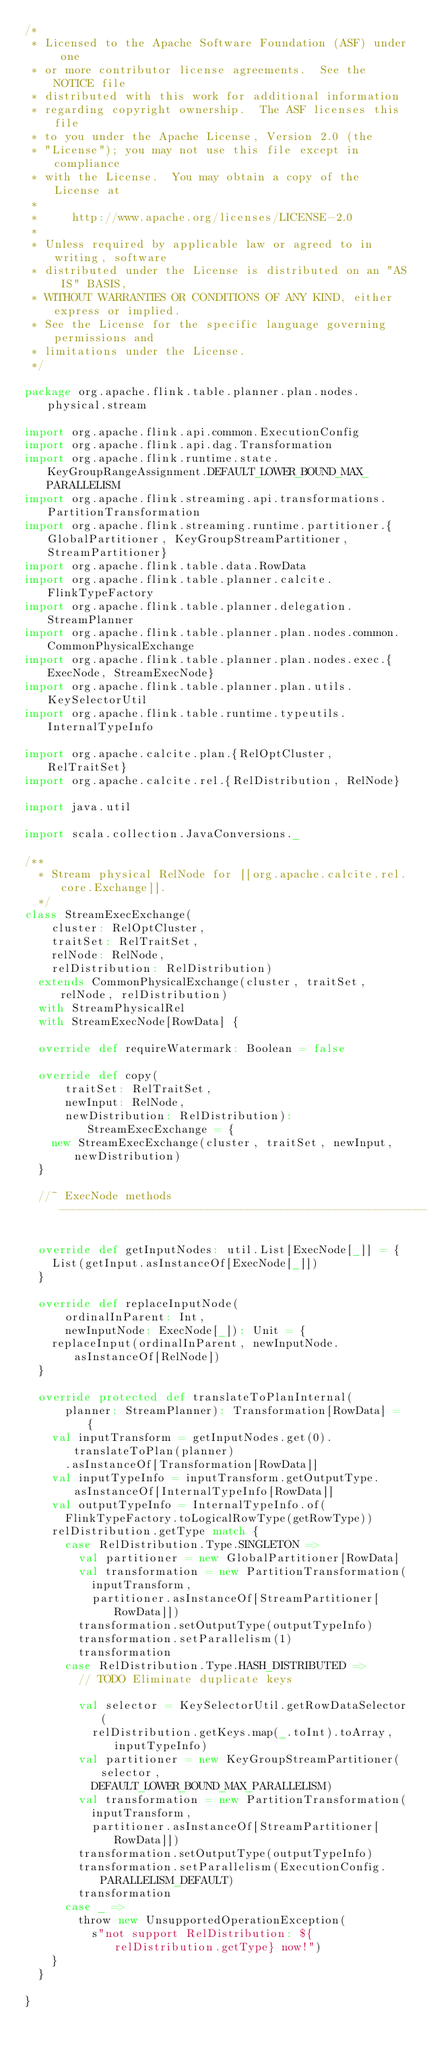<code> <loc_0><loc_0><loc_500><loc_500><_Scala_>/*
 * Licensed to the Apache Software Foundation (ASF) under one
 * or more contributor license agreements.  See the NOTICE file
 * distributed with this work for additional information
 * regarding copyright ownership.  The ASF licenses this file
 * to you under the Apache License, Version 2.0 (the
 * "License"); you may not use this file except in compliance
 * with the License.  You may obtain a copy of the License at
 *
 *     http://www.apache.org/licenses/LICENSE-2.0
 *
 * Unless required by applicable law or agreed to in writing, software
 * distributed under the License is distributed on an "AS IS" BASIS,
 * WITHOUT WARRANTIES OR CONDITIONS OF ANY KIND, either express or implied.
 * See the License for the specific language governing permissions and
 * limitations under the License.
 */

package org.apache.flink.table.planner.plan.nodes.physical.stream

import org.apache.flink.api.common.ExecutionConfig
import org.apache.flink.api.dag.Transformation
import org.apache.flink.runtime.state.KeyGroupRangeAssignment.DEFAULT_LOWER_BOUND_MAX_PARALLELISM
import org.apache.flink.streaming.api.transformations.PartitionTransformation
import org.apache.flink.streaming.runtime.partitioner.{GlobalPartitioner, KeyGroupStreamPartitioner, StreamPartitioner}
import org.apache.flink.table.data.RowData
import org.apache.flink.table.planner.calcite.FlinkTypeFactory
import org.apache.flink.table.planner.delegation.StreamPlanner
import org.apache.flink.table.planner.plan.nodes.common.CommonPhysicalExchange
import org.apache.flink.table.planner.plan.nodes.exec.{ExecNode, StreamExecNode}
import org.apache.flink.table.planner.plan.utils.KeySelectorUtil
import org.apache.flink.table.runtime.typeutils.InternalTypeInfo

import org.apache.calcite.plan.{RelOptCluster, RelTraitSet}
import org.apache.calcite.rel.{RelDistribution, RelNode}

import java.util

import scala.collection.JavaConversions._

/**
  * Stream physical RelNode for [[org.apache.calcite.rel.core.Exchange]].
  */
class StreamExecExchange(
    cluster: RelOptCluster,
    traitSet: RelTraitSet,
    relNode: RelNode,
    relDistribution: RelDistribution)
  extends CommonPhysicalExchange(cluster, traitSet, relNode, relDistribution)
  with StreamPhysicalRel
  with StreamExecNode[RowData] {

  override def requireWatermark: Boolean = false

  override def copy(
      traitSet: RelTraitSet,
      newInput: RelNode,
      newDistribution: RelDistribution): StreamExecExchange = {
    new StreamExecExchange(cluster, traitSet, newInput, newDistribution)
  }

  //~ ExecNode methods -----------------------------------------------------------

  override def getInputNodes: util.List[ExecNode[_]] = {
    List(getInput.asInstanceOf[ExecNode[_]])
  }

  override def replaceInputNode(
      ordinalInParent: Int,
      newInputNode: ExecNode[_]): Unit = {
    replaceInput(ordinalInParent, newInputNode.asInstanceOf[RelNode])
  }

  override protected def translateToPlanInternal(
      planner: StreamPlanner): Transformation[RowData] = {
    val inputTransform = getInputNodes.get(0).translateToPlan(planner)
      .asInstanceOf[Transformation[RowData]]
    val inputTypeInfo = inputTransform.getOutputType.asInstanceOf[InternalTypeInfo[RowData]]
    val outputTypeInfo = InternalTypeInfo.of(
      FlinkTypeFactory.toLogicalRowType(getRowType))
    relDistribution.getType match {
      case RelDistribution.Type.SINGLETON =>
        val partitioner = new GlobalPartitioner[RowData]
        val transformation = new PartitionTransformation(
          inputTransform,
          partitioner.asInstanceOf[StreamPartitioner[RowData]])
        transformation.setOutputType(outputTypeInfo)
        transformation.setParallelism(1)
        transformation
      case RelDistribution.Type.HASH_DISTRIBUTED =>
        // TODO Eliminate duplicate keys

        val selector = KeySelectorUtil.getRowDataSelector(
          relDistribution.getKeys.map(_.toInt).toArray, inputTypeInfo)
        val partitioner = new KeyGroupStreamPartitioner(selector,
          DEFAULT_LOWER_BOUND_MAX_PARALLELISM)
        val transformation = new PartitionTransformation(
          inputTransform,
          partitioner.asInstanceOf[StreamPartitioner[RowData]])
        transformation.setOutputType(outputTypeInfo)
        transformation.setParallelism(ExecutionConfig.PARALLELISM_DEFAULT)
        transformation
      case _ =>
        throw new UnsupportedOperationException(
          s"not support RelDistribution: ${relDistribution.getType} now!")
    }
  }

}
</code> 